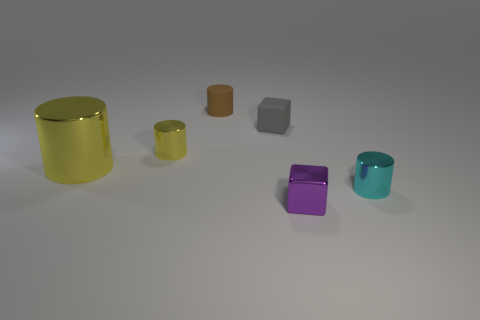The other matte object that is the same shape as the cyan thing is what size? The other matte object, which is a grey cube similar in shape to the cyan cube, appears to be small in size, comparable to the cyan cube, suggesting it is likely a small object within this collection. 